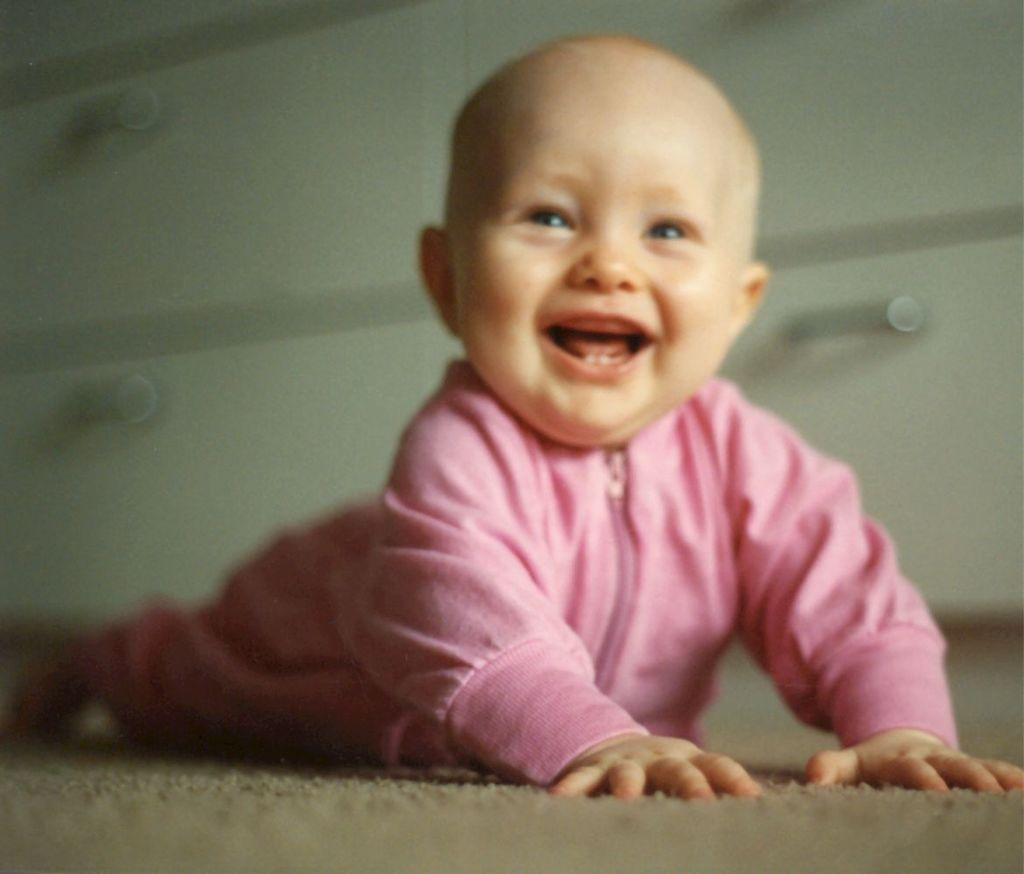What is the main subject of the image? There is a baby in the image. Where is the baby located in the image? The baby is on the floor. Can you describe the background of the image? The background of the image is blurred. What type of substance is the baby playing with in the image? There is no substance visible in the image; the baby is simply on the floor. Can you see a basket in the image? There is no basket present in the image. 